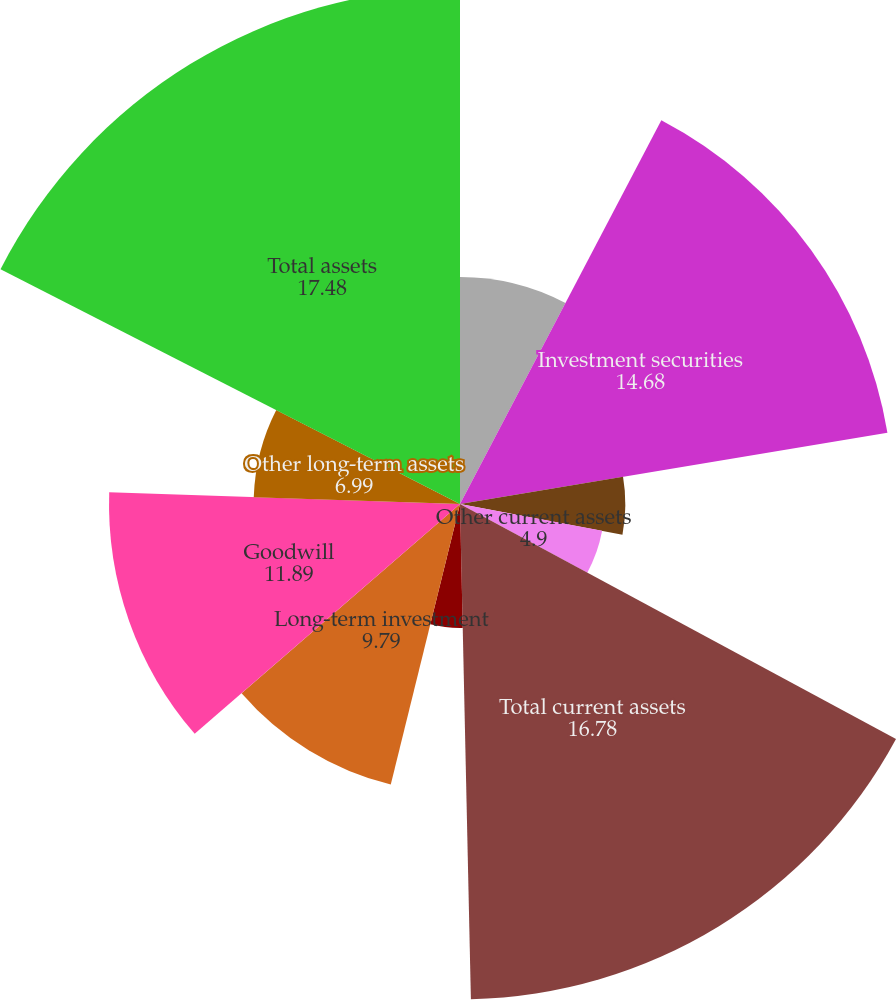Convert chart. <chart><loc_0><loc_0><loc_500><loc_500><pie_chart><fcel>Cash and cash equivalents<fcel>Investment securities<fcel>Receivables less allowance for<fcel>Other current assets<fcel>Total current assets<fcel>Property and equipment net<fcel>Long-term investment<fcel>Goodwill<fcel>Other long-term assets<fcel>Total assets<nl><fcel>7.69%<fcel>14.68%<fcel>5.6%<fcel>4.9%<fcel>16.78%<fcel>4.2%<fcel>9.79%<fcel>11.89%<fcel>6.99%<fcel>17.48%<nl></chart> 